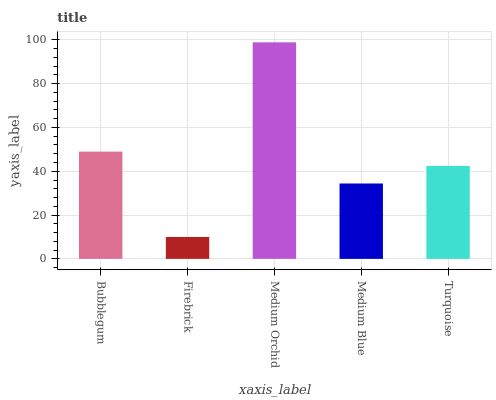Is Medium Orchid the minimum?
Answer yes or no. No. Is Firebrick the maximum?
Answer yes or no. No. Is Medium Orchid greater than Firebrick?
Answer yes or no. Yes. Is Firebrick less than Medium Orchid?
Answer yes or no. Yes. Is Firebrick greater than Medium Orchid?
Answer yes or no. No. Is Medium Orchid less than Firebrick?
Answer yes or no. No. Is Turquoise the high median?
Answer yes or no. Yes. Is Turquoise the low median?
Answer yes or no. Yes. Is Medium Orchid the high median?
Answer yes or no. No. Is Firebrick the low median?
Answer yes or no. No. 